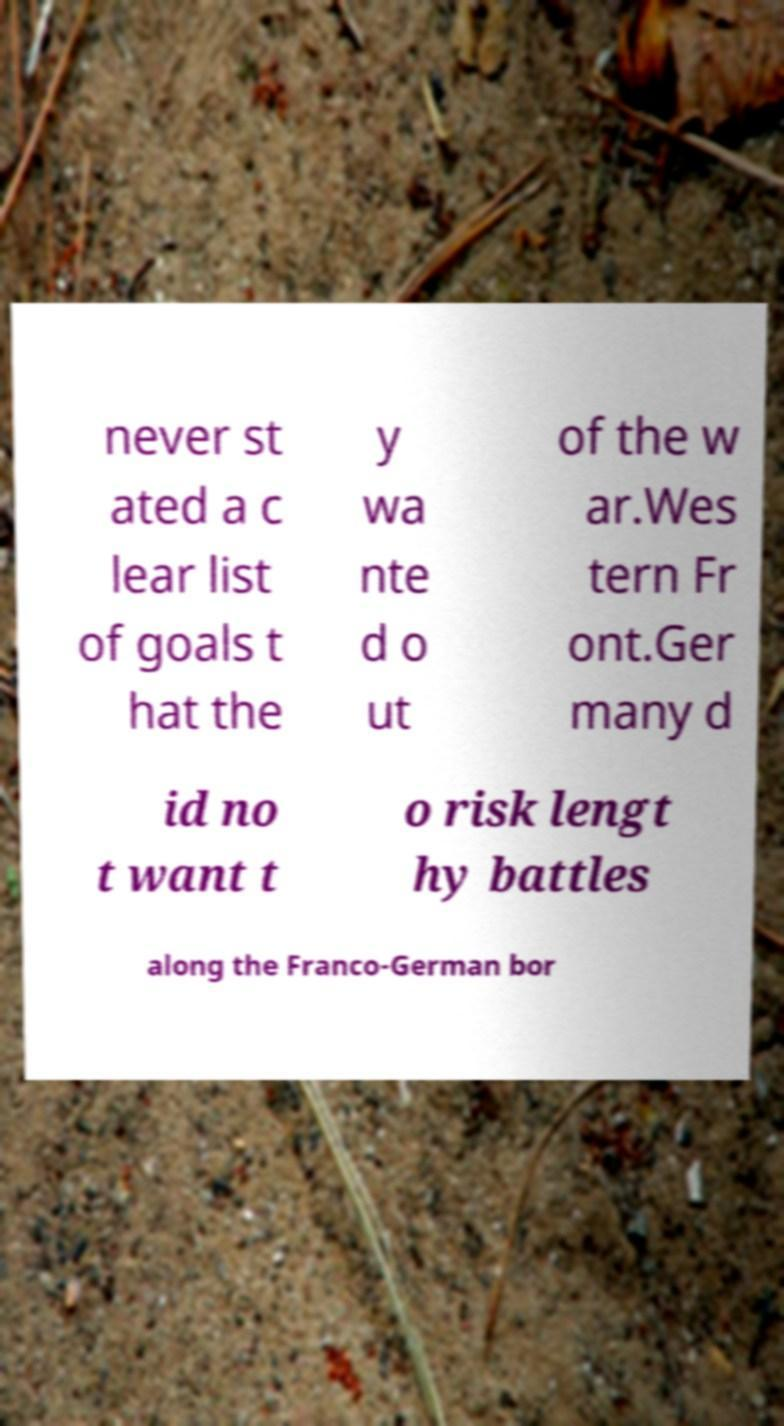Can you read and provide the text displayed in the image?This photo seems to have some interesting text. Can you extract and type it out for me? never st ated a c lear list of goals t hat the y wa nte d o ut of the w ar.Wes tern Fr ont.Ger many d id no t want t o risk lengt hy battles along the Franco-German bor 